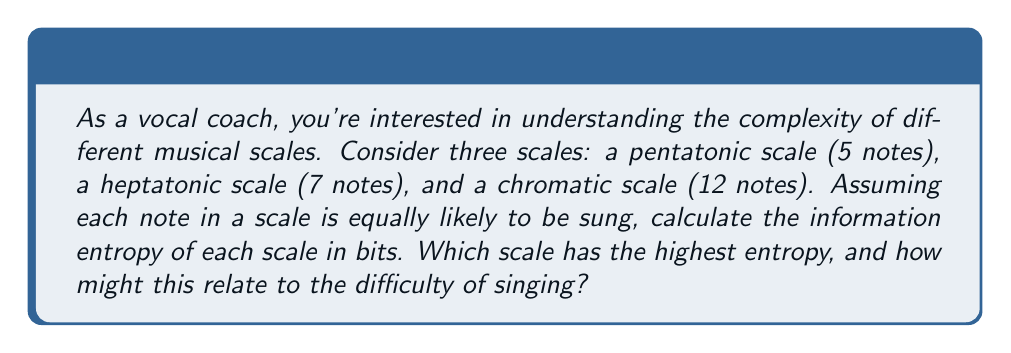Teach me how to tackle this problem. To calculate the information entropy of each scale, we'll use the formula for Shannon entropy:

$$H = -\sum_{i=1}^{n} p_i \log_2(p_i)$$

Where $H$ is the entropy, $n$ is the number of possible outcomes (notes in this case), and $p_i$ is the probability of each outcome.

1. Pentatonic scale (5 notes):
   Each note has a probability of $\frac{1}{5}$.
   $$H_{pentatonic} = -5 \cdot \frac{1}{5} \log_2(\frac{1}{5}) = -\log_2(\frac{1}{5}) = \log_2(5) \approx 2.32 \text{ bits}$$

2. Heptatonic scale (7 notes):
   Each note has a probability of $\frac{1}{7}$.
   $$H_{heptatonic} = -7 \cdot \frac{1}{7} \log_2(\frac{1}{7}) = -\log_2(\frac{1}{7}) = \log_2(7) \approx 2.81 \text{ bits}$$

3. Chromatic scale (12 notes):
   Each note has a probability of $\frac{1}{12}$.
   $$H_{chromatic} = -12 \cdot \frac{1}{12} \log_2(\frac{1}{12}) = -\log_2(\frac{1}{12}) = \log_2(12) \approx 3.58 \text{ bits}$$

The chromatic scale has the highest entropy, which suggests it contains the most information. This aligns with the intuition that it's more challenging to sing, as there are more possible notes to choose from and distinguish between. The pentatonic scale, with the lowest entropy, is often considered easier for beginners to sing, as it contains fewer notes and thus less information to process.
Answer: Pentatonic scale: $\log_2(5) \approx 2.32$ bits
Heptatonic scale: $\log_2(7) \approx 2.81$ bits
Chromatic scale: $\log_2(12) \approx 3.58$ bits

The chromatic scale has the highest entropy, potentially making it the most challenging to sing due to its greater information content. 